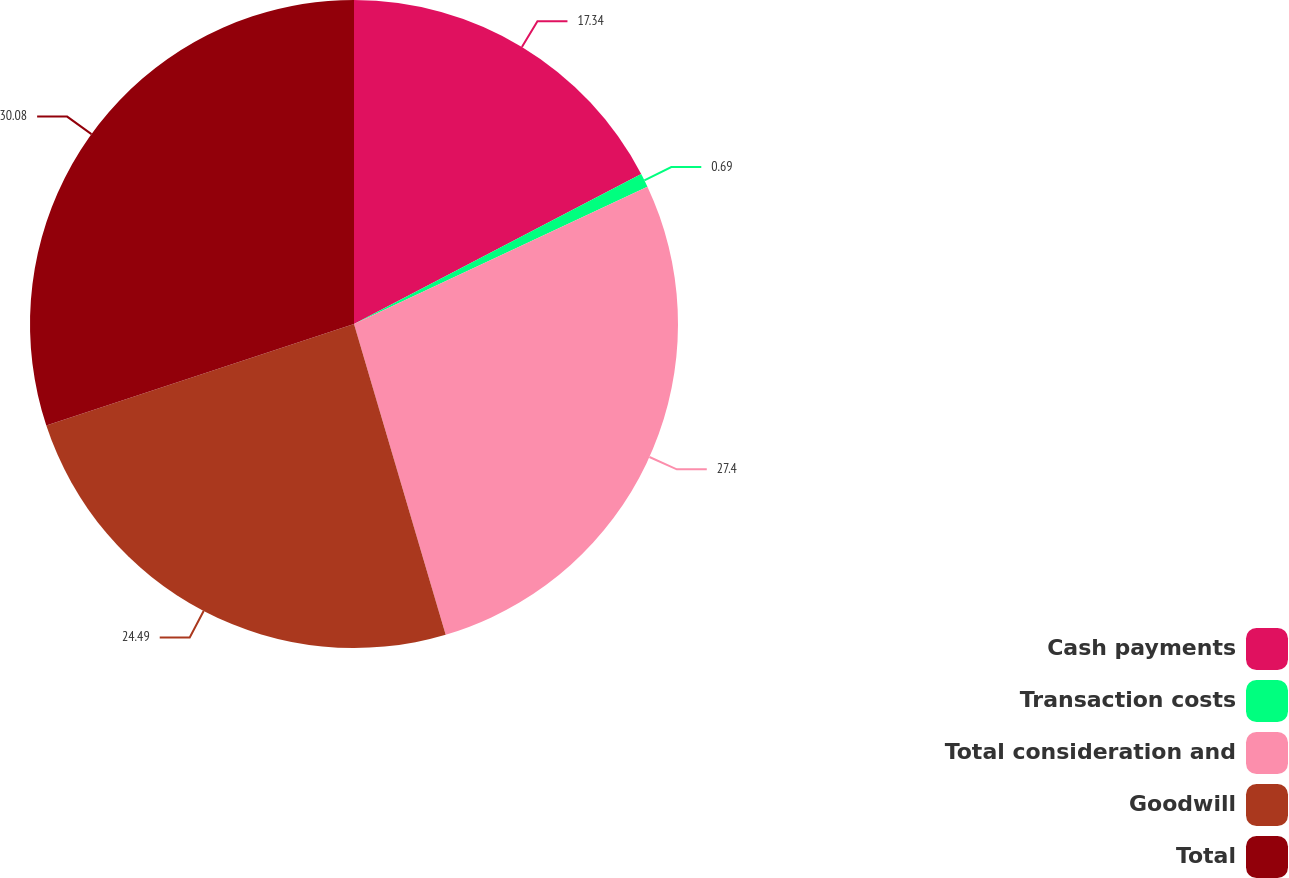Convert chart. <chart><loc_0><loc_0><loc_500><loc_500><pie_chart><fcel>Cash payments<fcel>Transaction costs<fcel>Total consideration and<fcel>Goodwill<fcel>Total<nl><fcel>17.34%<fcel>0.69%<fcel>27.4%<fcel>24.49%<fcel>30.07%<nl></chart> 